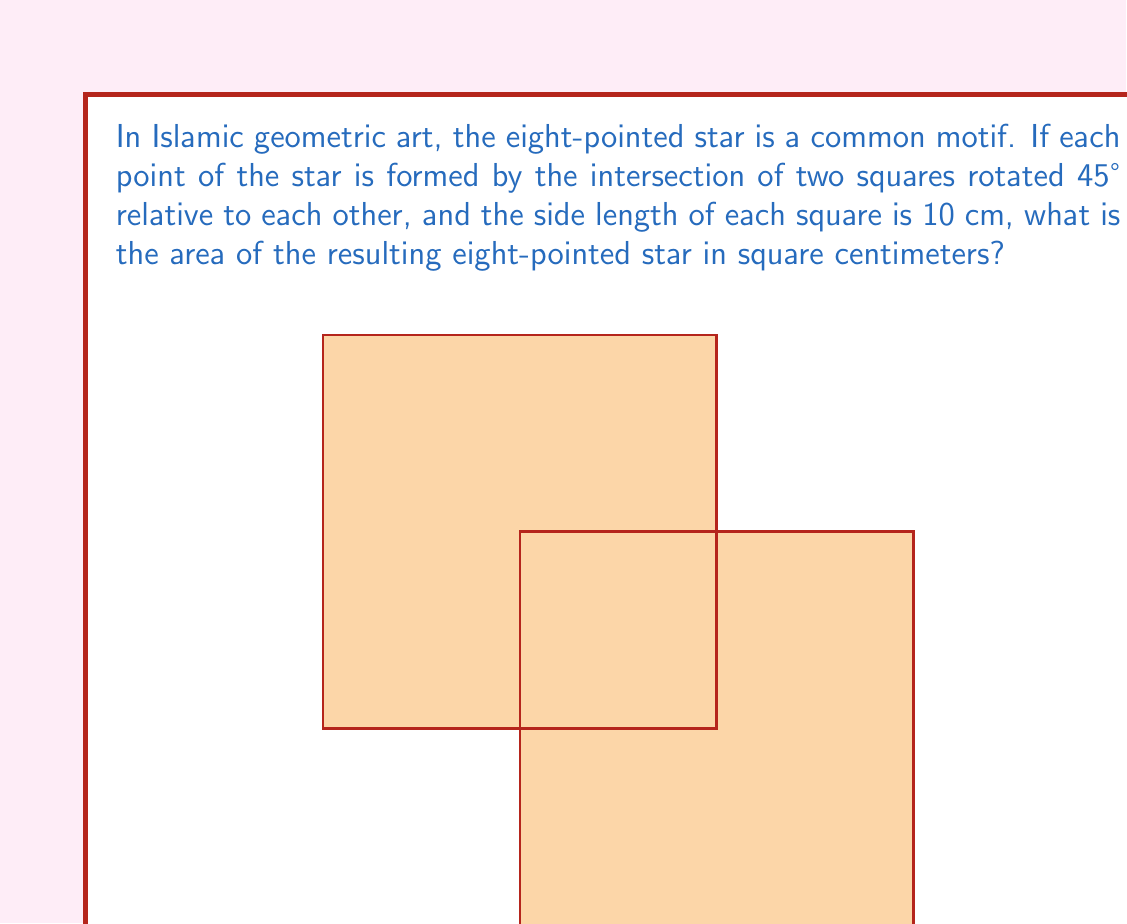Solve this math problem. To solve this problem, let's break it down into steps:

1) First, we need to understand the shape. The eight-pointed star is formed by the overlap of two squares, each rotated 45° relative to the other.

2) The area of the star will be the sum of the areas of both squares, minus the area of their overlap.

3) The area of each square is simple to calculate:
   $A_{square} = s^2 = 10^2 = 100$ cm²

4) The total area of both squares is:
   $A_{total} = 2 * 100 = 200$ cm²

5) Now, we need to calculate the area of overlap. The overlap forms an octagon in the center.

6) To find the area of this octagon, we can use the formula:
   $A_{octagon} = 2a^2(1+\sqrt{2})$
   where $a$ is the side length of the octagon.

7) To find $a$, we need to realize that it's the difference between the radius of the circumscribed circle of the square (which is $5\sqrt{2}$ cm) and half the side of the square (5 cm):
   $a = 5\sqrt{2} - 5 = 5(\sqrt{2}-1)$ cm

8) Now we can calculate the area of the octagon:
   $A_{octagon} = 2(5(\sqrt{2}-1))^2(1+\sqrt{2})$
                $= 50(3-2\sqrt{2})(\sqrt{2}+1)$
                $= 50(3\sqrt{2}+3-4-2\sqrt{2})$
                $= 50(\sqrt{2}-1)$
                $= 50(\sqrt{2}-1)$
                $\approx 20.71$ cm²

9) Therefore, the area of the eight-pointed star is:
   $A_{star} = A_{total} - A_{octagon}$
              $= 200 - 50(\sqrt{2}-1)$
              $= 200 - 50\sqrt{2} + 50$
              $= 250 - 50\sqrt{2}$
              $\approx 179.29$ cm²
Answer: The area of the eight-pointed star is $250 - 50\sqrt{2}$ cm², or approximately 179.29 cm². 